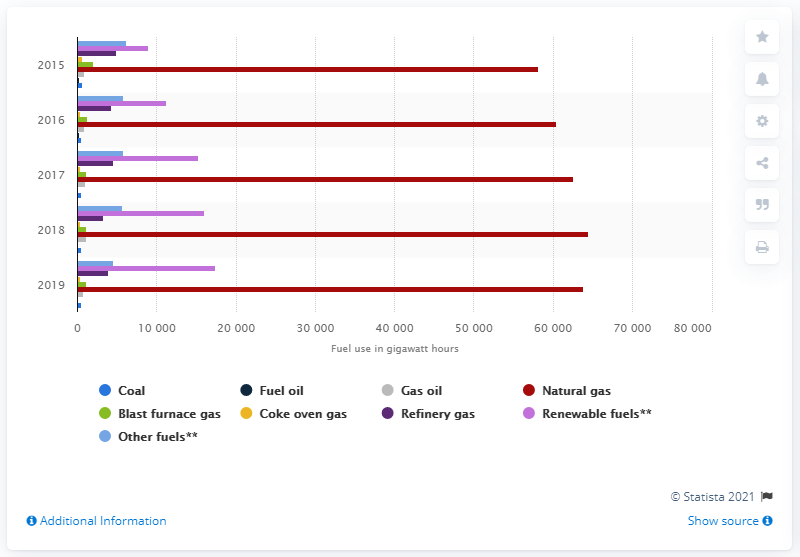List a handful of essential elements in this visual. Natural gas is the most commonly used fuel for combined heat and power in the UK since 2015. 